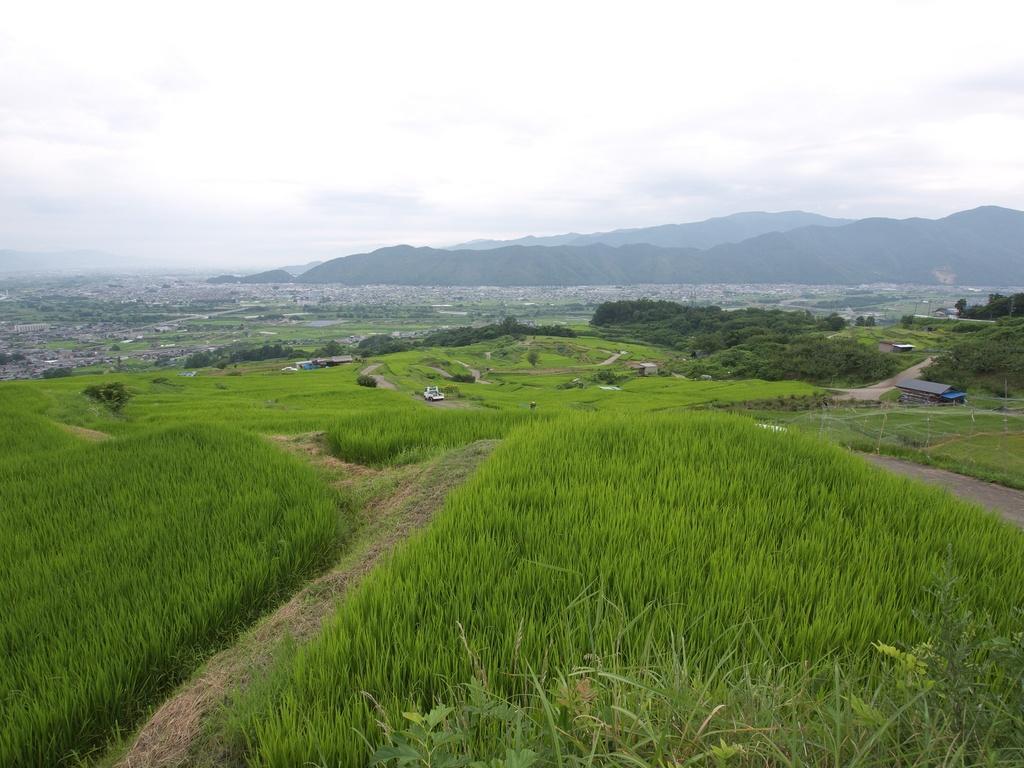Describe this image in one or two sentences. In this picture we can see grass, few houses, trees and hills. 